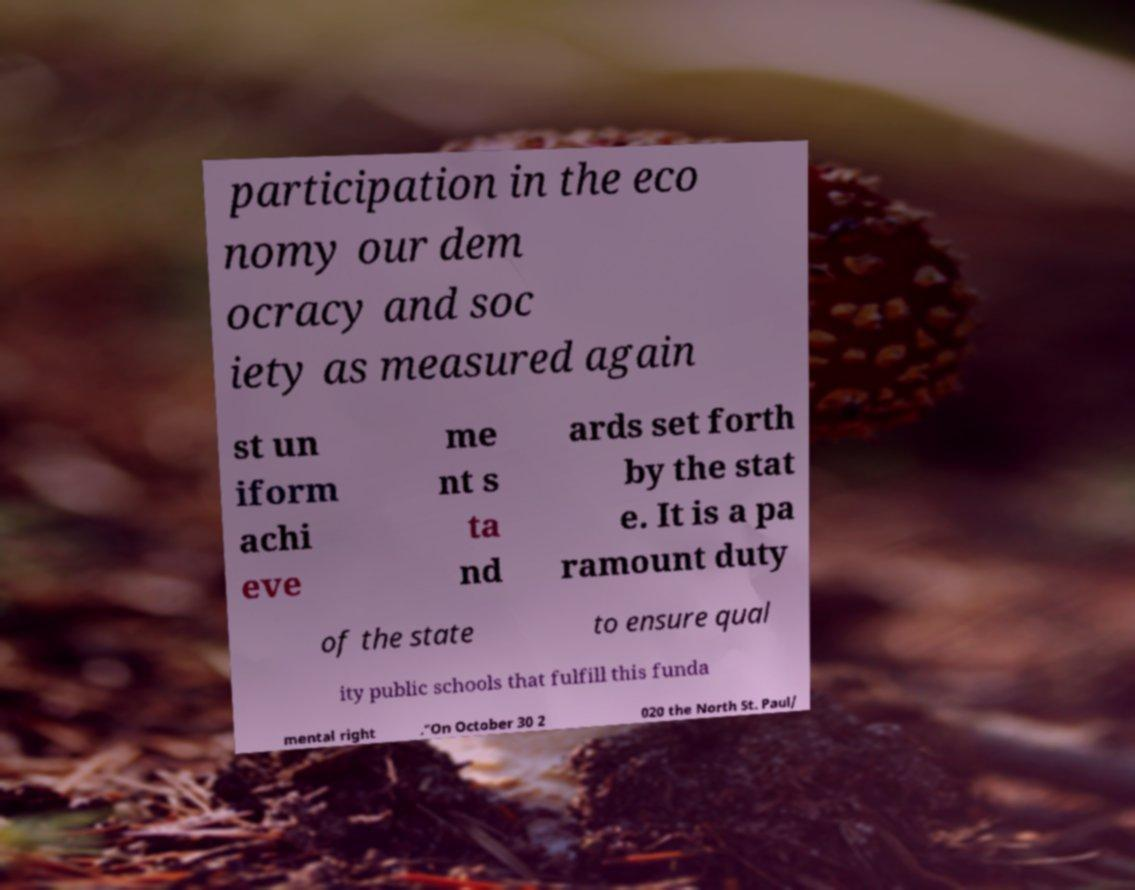There's text embedded in this image that I need extracted. Can you transcribe it verbatim? participation in the eco nomy our dem ocracy and soc iety as measured again st un iform achi eve me nt s ta nd ards set forth by the stat e. It is a pa ramount duty of the state to ensure qual ity public schools that fulfill this funda mental right ."On October 30 2 020 the North St. Paul/ 